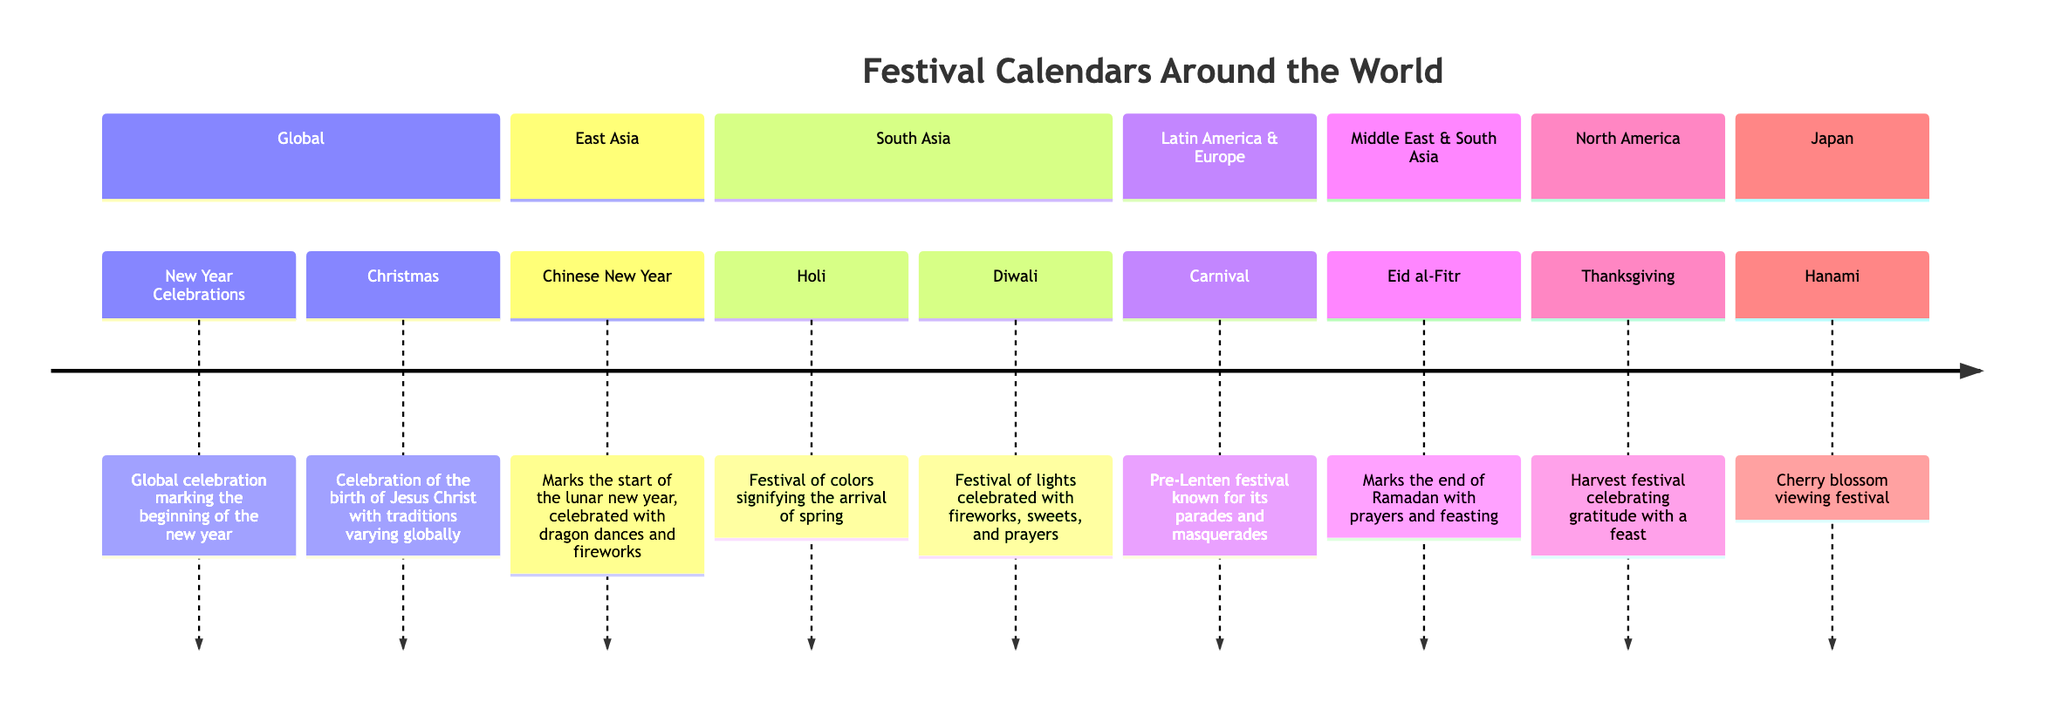What is celebrated globally at the start of the new year? The diagram mentions "New Year Celebrations" under the Global section, indicating it marks the onset of the new year with worldwide festivities.
Answer: New Year Celebrations How many festivals are listed under East Asia? The East Asia section contains one festival, which is "Chinese New Year." Thus, the total count is one.
Answer: 1 Which festival signifies the arrival of spring in South Asia? The diagram specifies "Holi" under the South Asia section as the festival that represents the arrival of spring, noting its significance in the region.
Answer: Holi What festival involves cherry blossom viewing? The diagram indicates "Hanami" under the Japan section as the festival dedicated to viewing cherry blossoms, highlighting the cultural practice in Japan.
Answer: Hanami What is celebrated during Eid al-Fitr? Eid al-Fitr celebrates the end of Ramadan with activities including prayers and feasting, which is specified in the Middle East & South Asia section.
Answer: End of Ramadan Which festival is characterized by parades and masquerades? According to the diagram, "Carnival" in the Latin America & Europe section is noted for its parades and masquerades, showcasing the festival's lively nature.
Answer: Carnival Which region celebrates Thanksgiving? The North America section of the diagram specifies Thanksgiving as the harvest celebration that takes place in this region, identifying the cultural importance.
Answer: North America What is the primary theme of Diwali? Diwali is described as the "Festival of lights" celebrated with fireworks and sweets in the South Asia section, highlighting its central theme of illumination and joy.
Answer: Festival of lights How many total sections are there in the timeline? The diagram has six distinct sections: Global, East Asia, South Asia, Latin America & Europe, Middle East & South Asia, and North America, resulting in a total of six sections.
Answer: 6 